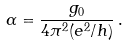<formula> <loc_0><loc_0><loc_500><loc_500>\alpha = \frac { g _ { 0 } } { 4 \pi ^ { 2 } ( e ^ { 2 } / h ) } \, .</formula> 